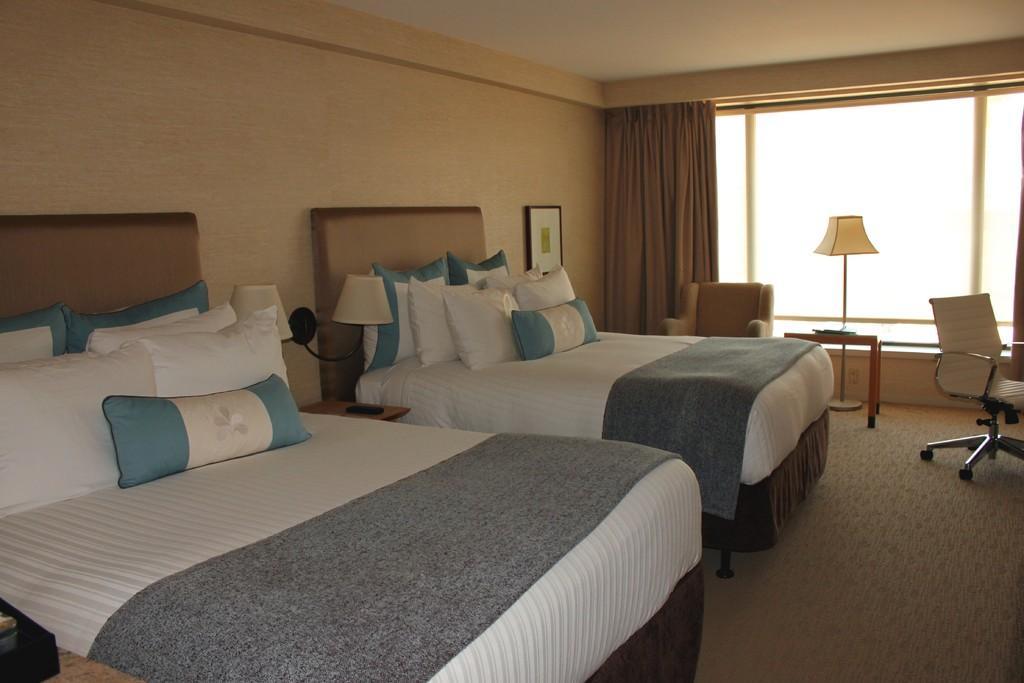Can you describe this image briefly? In the foreground, I can see cushions on two beds and lamps on tables. In the background, I can see chairs, wall painting on a wall, glass window, curtain and so on. This image taken, maybe in a hall. 